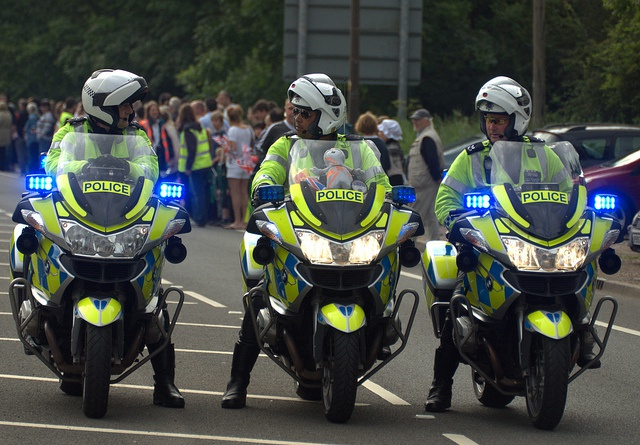Describe the objects in this image and their specific colors. I can see motorcycle in black, gray, navy, and darkgray tones, motorcycle in black, gray, darkgray, and navy tones, motorcycle in black, gray, navy, and darkgray tones, people in black, gray, darkgray, and green tones, and people in black, darkgray, gray, and olive tones in this image. 